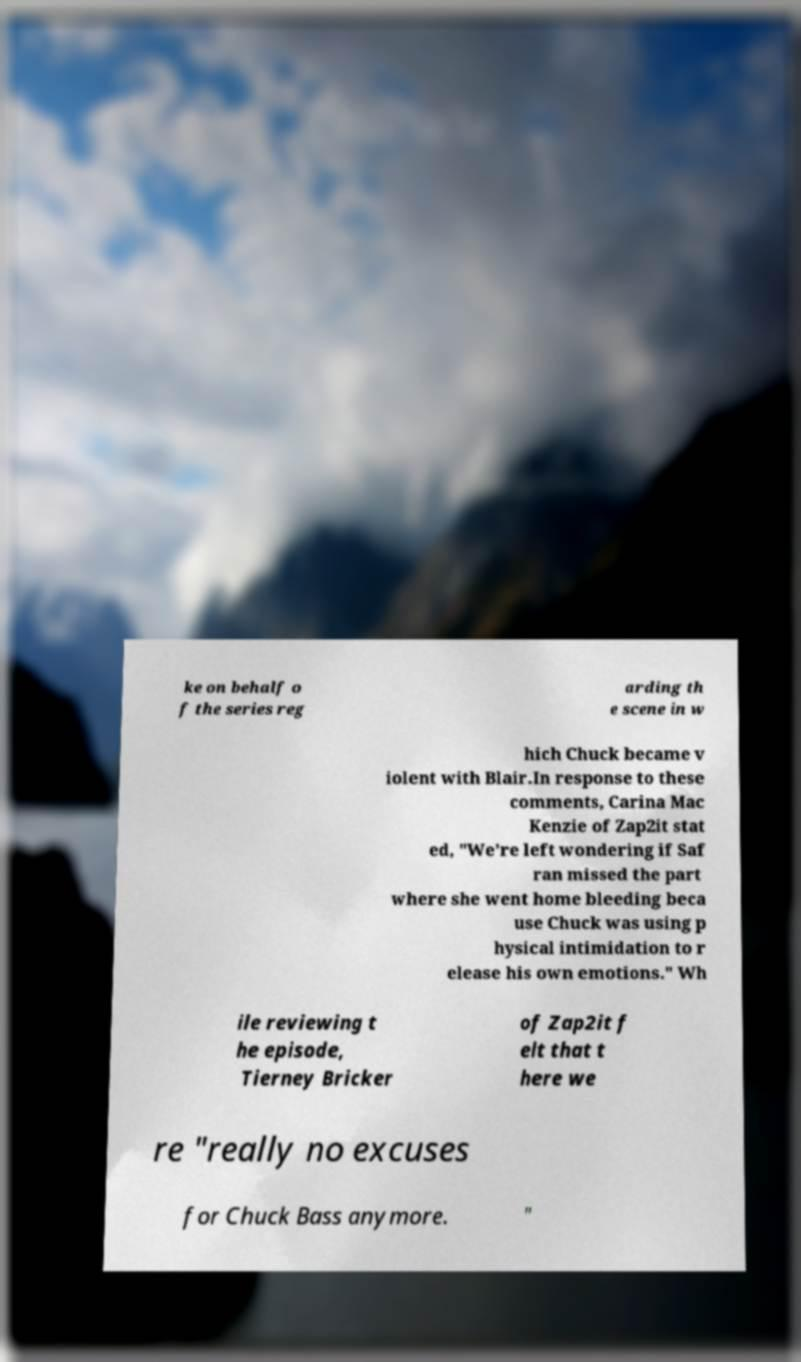What messages or text are displayed in this image? I need them in a readable, typed format. ke on behalf o f the series reg arding th e scene in w hich Chuck became v iolent with Blair.In response to these comments, Carina Mac Kenzie of Zap2it stat ed, "We're left wondering if Saf ran missed the part where she went home bleeding beca use Chuck was using p hysical intimidation to r elease his own emotions." Wh ile reviewing t he episode, Tierney Bricker of Zap2it f elt that t here we re "really no excuses for Chuck Bass anymore. " 